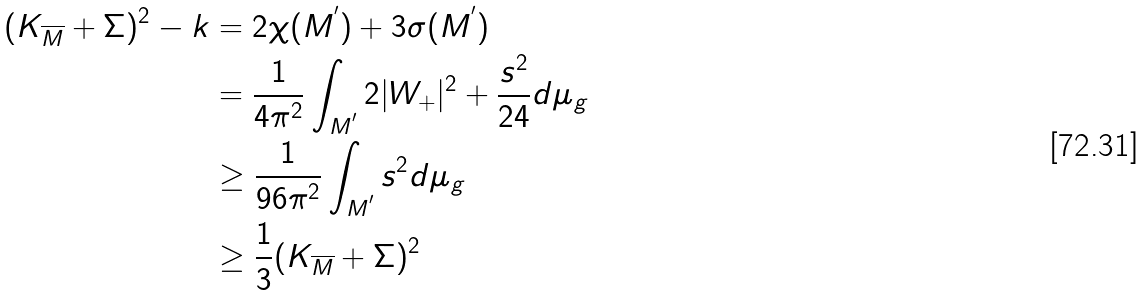Convert formula to latex. <formula><loc_0><loc_0><loc_500><loc_500>( K _ { \overline { M } } + \Sigma ) ^ { 2 } - k & = 2 \chi ( M ^ { ^ { \prime } } ) + 3 \sigma ( M ^ { ^ { \prime } } ) \\ & = \frac { 1 } { 4 \pi ^ { 2 } } \int _ { M ^ { ^ { \prime } } } 2 | W _ { + } | ^ { 2 } + \frac { s ^ { 2 } } { 2 4 } d \mu _ { g } \\ & \geq \frac { 1 } { 9 6 \pi ^ { 2 } } \int _ { M ^ { ^ { \prime } } } s ^ { 2 } d \mu _ { g } \\ & \geq \frac { 1 } { 3 } ( K _ { \overline { M } } + \Sigma ) ^ { 2 }</formula> 